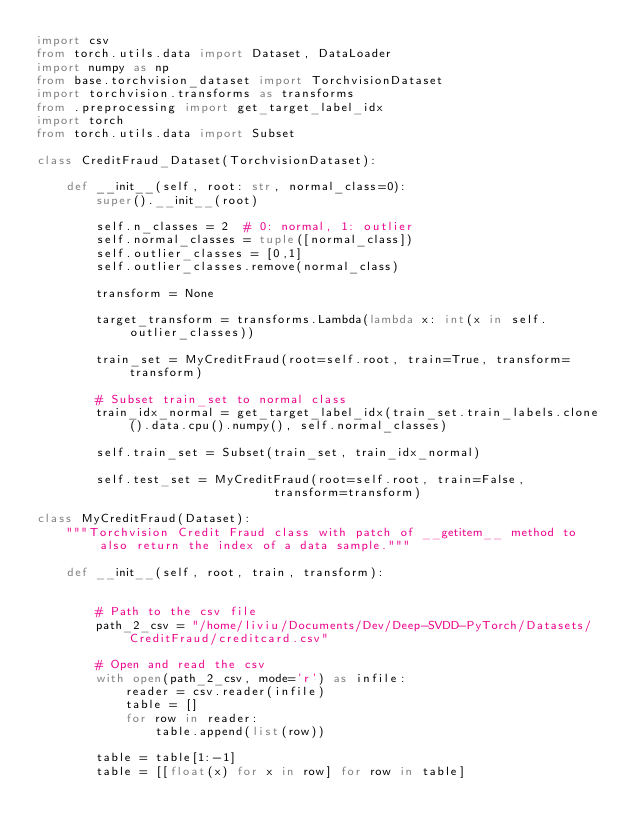Convert code to text. <code><loc_0><loc_0><loc_500><loc_500><_Python_>import csv
from torch.utils.data import Dataset, DataLoader
import numpy as np
from base.torchvision_dataset import TorchvisionDataset
import torchvision.transforms as transforms
from .preprocessing import get_target_label_idx
import torch
from torch.utils.data import Subset

class CreditFraud_Dataset(TorchvisionDataset):

    def __init__(self, root: str, normal_class=0):
        super().__init__(root)

        self.n_classes = 2  # 0: normal, 1: outlier
        self.normal_classes = tuple([normal_class])
        self.outlier_classes = [0,1]
        self.outlier_classes.remove(normal_class)

        transform = None

        target_transform = transforms.Lambda(lambda x: int(x in self.outlier_classes))

        train_set = MyCreditFraud(root=self.root, train=True, transform=transform)

        # Subset train_set to normal class
        train_idx_normal = get_target_label_idx(train_set.train_labels.clone().data.cpu().numpy(), self.normal_classes)

        self.train_set = Subset(train_set, train_idx_normal)

        self.test_set = MyCreditFraud(root=self.root, train=False,
                                transform=transform)

class MyCreditFraud(Dataset):
    """Torchvision Credit Fraud class with patch of __getitem__ method to also return the index of a data sample."""

    def __init__(self, root, train, transform):


        # Path to the csv file
        path_2_csv = "/home/liviu/Documents/Dev/Deep-SVDD-PyTorch/Datasets/CreditFraud/creditcard.csv"

        # Open and read the csv
        with open(path_2_csv, mode='r') as infile:
            reader = csv.reader(infile)
            table = []
            for row in reader:
                table.append(list(row))

        table = table[1:-1]        
        table = [[float(x) for x in row] for row in table]
</code> 